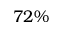Convert formula to latex. <formula><loc_0><loc_0><loc_500><loc_500>7 2 \%</formula> 